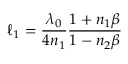<formula> <loc_0><loc_0><loc_500><loc_500>\ell _ { 1 } = \frac { \lambda _ { 0 } } { 4 n _ { 1 } } \frac { 1 + n _ { 1 } \beta } { 1 - n _ { 2 } \beta }</formula> 